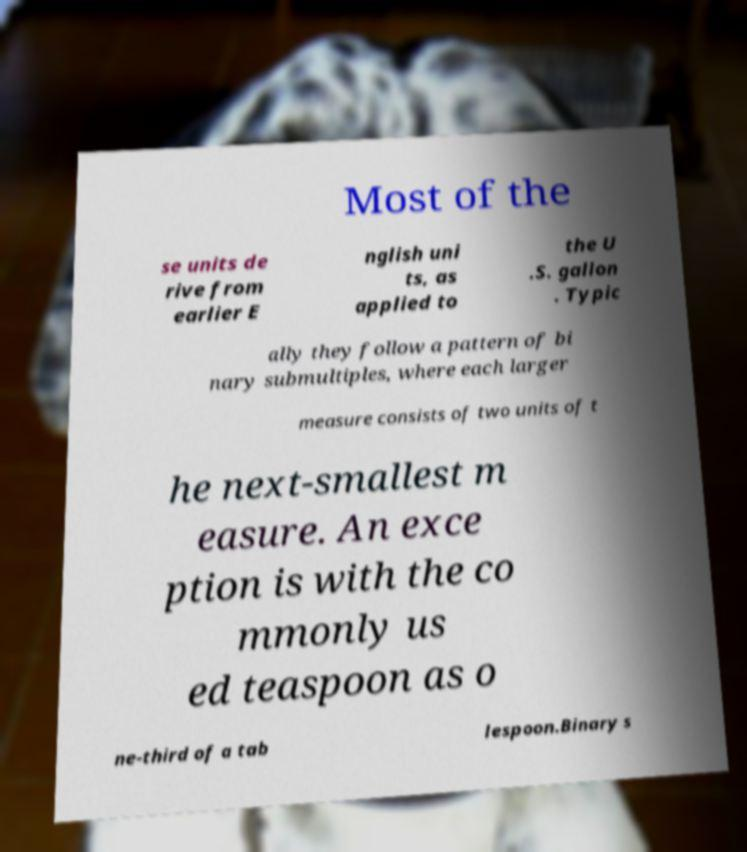For documentation purposes, I need the text within this image transcribed. Could you provide that? Most of the se units de rive from earlier E nglish uni ts, as applied to the U .S. gallon . Typic ally they follow a pattern of bi nary submultiples, where each larger measure consists of two units of t he next-smallest m easure. An exce ption is with the co mmonly us ed teaspoon as o ne-third of a tab lespoon.Binary s 